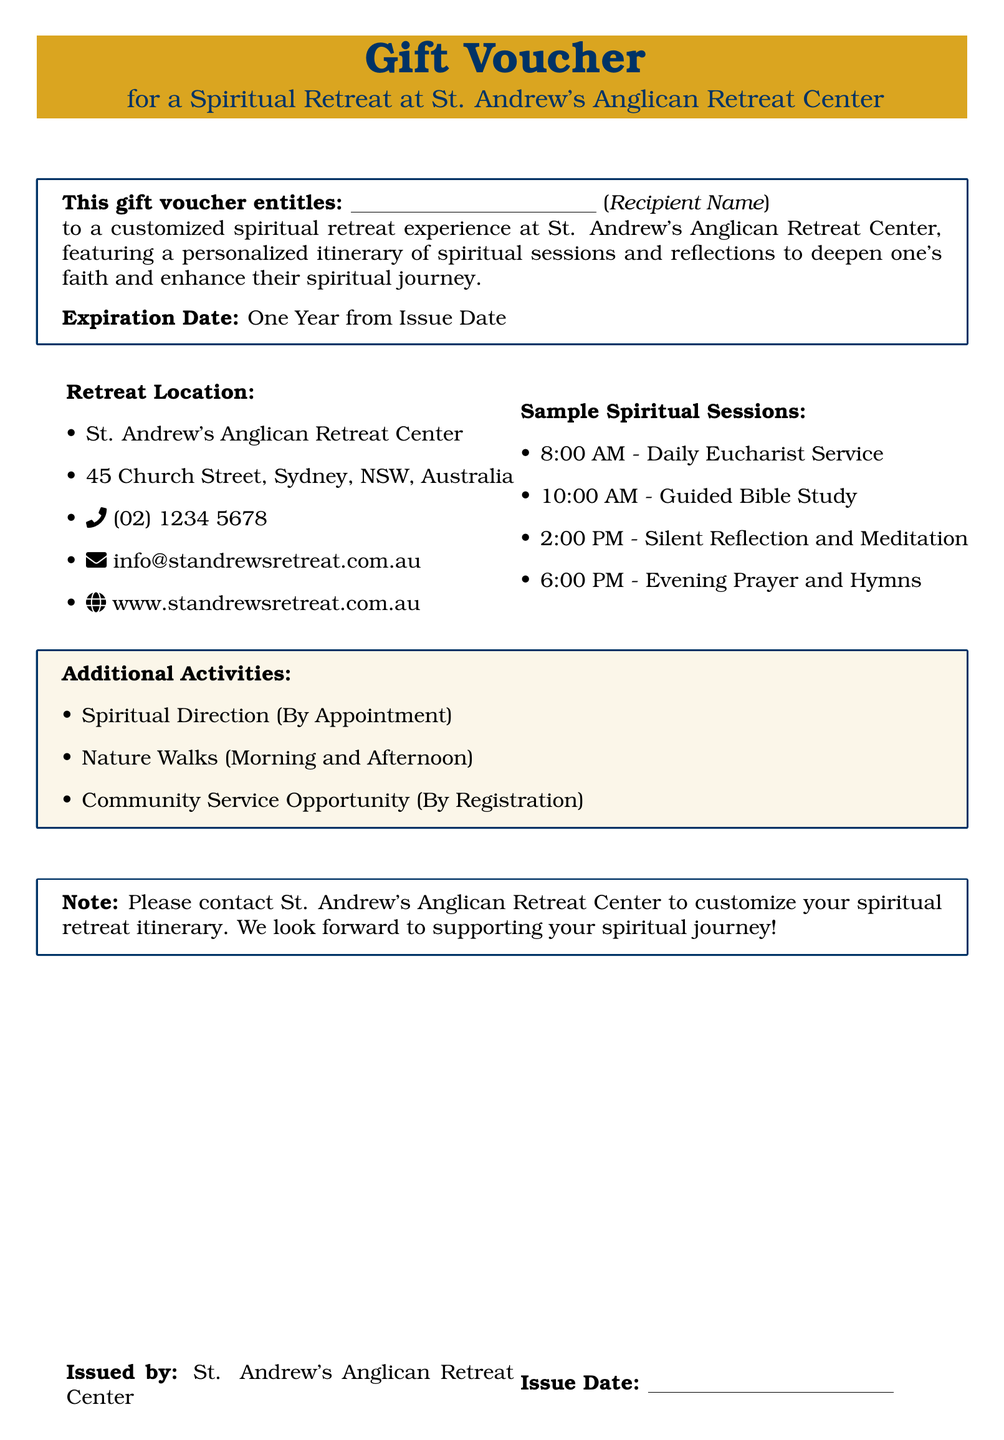What is the name of the retreat center? The name of the retreat center is mentioned in the title and body of the document, which is St. Andrew's Anglican Retreat Center.
Answer: St. Andrew's Anglican Retreat Center What is the phone number for the retreat center? The phone number is listed under the retreat location details in the document.
Answer: (02) 1234 5678 What is the expiration date of the voucher? The expiration date is stated directly in the document as one year from the issue date.
Answer: One Year from Issue Date What activities require an appointment or registration? The document specifies activities that require an appointment or registration in the Additional Activities section.
Answer: Spiritual Direction (By Appointment) and Community Service Opportunity (By Registration) What time does the Daily Eucharist Service start? The time for the Daily Eucharist Service is included in the Sample Spiritual Sessions section of the document.
Answer: 8:00 AM 